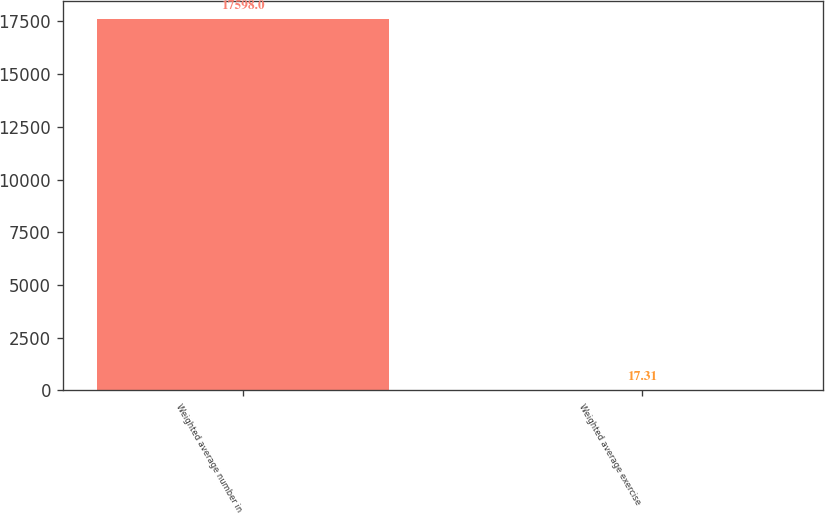<chart> <loc_0><loc_0><loc_500><loc_500><bar_chart><fcel>Weighted average number in<fcel>Weighted average exercise<nl><fcel>17598<fcel>17.31<nl></chart> 